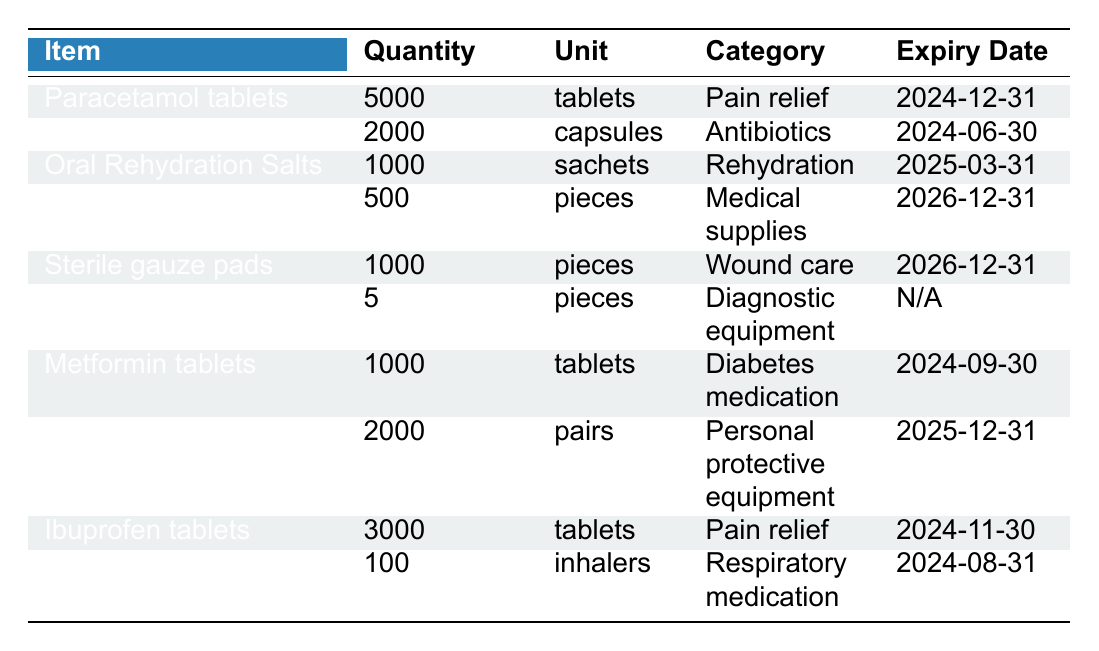What is the total quantity of Paracetamol tablets available? The table lists Paracetamol tablets with a quantity of 5000. Since there is only one entry for Paracetamol, the total quantity is simply 5000.
Answer: 5000 How many pieces of Disposable syringes do we have? The entry for Disposable syringes shows a quantity of 500 pieces. Therefore, the answer is directly taken from the table.
Answer: 500 Which medication has the earliest expiry date? By examining the expiry dates of all items, Amoxicillin capsules with an expiry date of 2024-06-30 has the earliest date compared to others listed.
Answer: Amoxicillin capsules What is the combined total quantity of Pain relief medications? The Pain relief medications listed are Paracetamol tablets (5000) and Ibuprofen tablets (3000). Adding these gives a total of 5000 + 3000 = 8000.
Answer: 8000 Are there any items that do not have an expiry date? The Blood pressure monitor has an entry listed as "N/A" for its expiry date, indicating it does not have a defined expiry date.
Answer: Yes What is the average quantity of all medications listed in the inventory? The total quantity of all medications is 5000 + 2000 + 1000 + 500 + 1000 + 5 + 1000 + 2000 + 3000 + 100. This equals 11808. There are 10 items in total, so the average is 11808 / 10 = 1180.8.
Answer: 1180.8 Is there a respiratory medication included in the inventory? The table lists Salbutamol inhaler under the category of Respiratory medication. Hence, the answer is affirmative.
Answer: Yes How many more pairs of Disposable gloves are there compared to Disposable syringes? Disposable gloves quantity is 2000 pairs, and Disposable syringes are 500 pieces. The difference is calculated as 2000 - 500 = 1500.
Answer: 1500 What proportion of the total quantity is made up by Oral Rehydration Salts? The total quantity of inventory items is 11808 and the quantity of Oral Rehydration Salts is 1000. The proportion is 1000 / 11808 ≈ 0.0847, meaning Oral Rehydration Salts make up approximately 8.47% of total inventory.
Answer: 8.47% Which category has the least number of items available? Considering the quantities, Blood pressure monitor with 5 pieces in the Diagnostic equipment category has the least quantity across all items.
Answer: Diagnostic equipment 